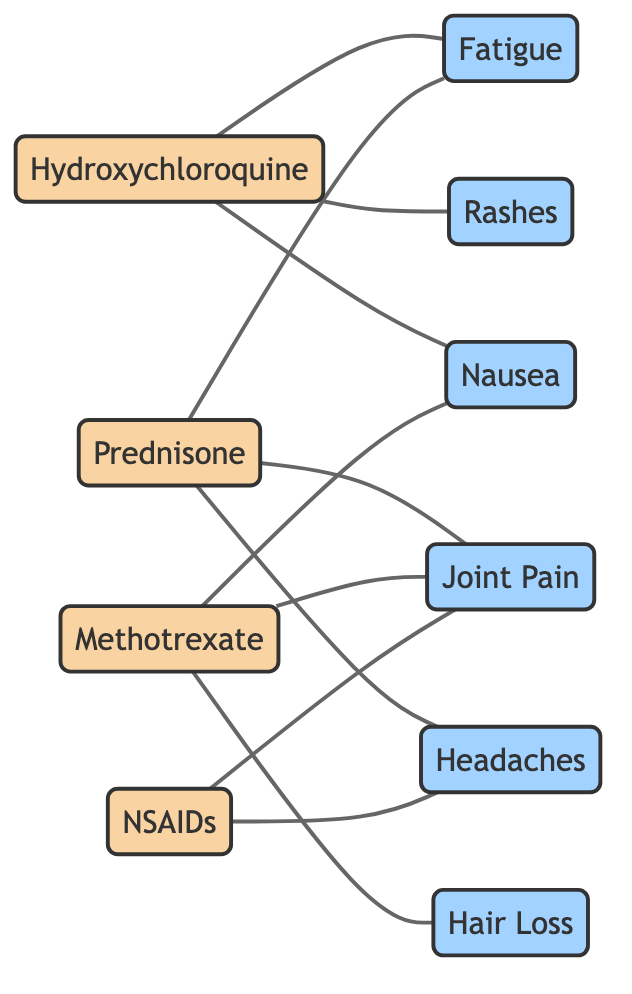What medications are linked to fatigue? In the diagram, I will identify the nodes connected to the "Fatigue" symptom node. The edges originating from nodes indicate a direct link. The medications that have an edge connected to "Fatigue" are Hydroxychloroquine and Prednisone.
Answer: Hydroxychloroquine, Prednisone How many symptoms are shown in the diagram? I can count the nodes categorized as symptoms in the diagram. The symptoms listed are Fatigue, Joint Pain, Rashes, Headaches, Nausea, and Hair Loss, totaling six.
Answer: 6 Which medication is associated with hair loss? To find out which medication is linked to hair loss, I will check the edges connected to the "Hair Loss" symptom. The edge indicates that Methotrexate is the only medication connected to this symptom.
Answer: Methotrexate What is the total number of edges in the diagram? To get the total number of edges, I will count all the connections between medications and symptoms shown in the diagram. There are a total of 10 edges.
Answer: 10 Which two medications are linked to joint pain? I need to look at the edges connected to the "Joint Pain" symptom. The medications that connect to this symptom are Prednisone, Methotrexate, and NSAIDs, indicating they are all linked to joint pain.
Answer: Prednisone, Methotrexate, NSAIDs Which symptom is linked to both Hydroxychloroquine and Methotrexate? To answer this, I will examine the edges connected to Hydroxychloroquine and Methotrexate, focusing on common links. The symptom "Nausea" has edges connecting to both Hydroxychloroquine and Methotrexate.
Answer: Nausea How many medications are linked to headaches? Looking at the edges connected to the "Headaches" symptom, the medications linked are Prednisone and NSAIDs. After counting the edges, I find that there is a total of two medications linked to headaches.
Answer: 2 What is the relationship between NSAIDs and joint pain? In the diagram, I will identify the edge between the medication NSAIDs and the symptom Joint Pain. There is a direct edge connecting the two, indicating that NSAIDs are associated with joint pain.
Answer: Linked Which symptom is only associated with one medication? I need to look for symptoms connected to medications that are not shared with others. Hair Loss is only connected to Methotrexate, making it the symptom associated with only one medication.
Answer: Hair Loss 